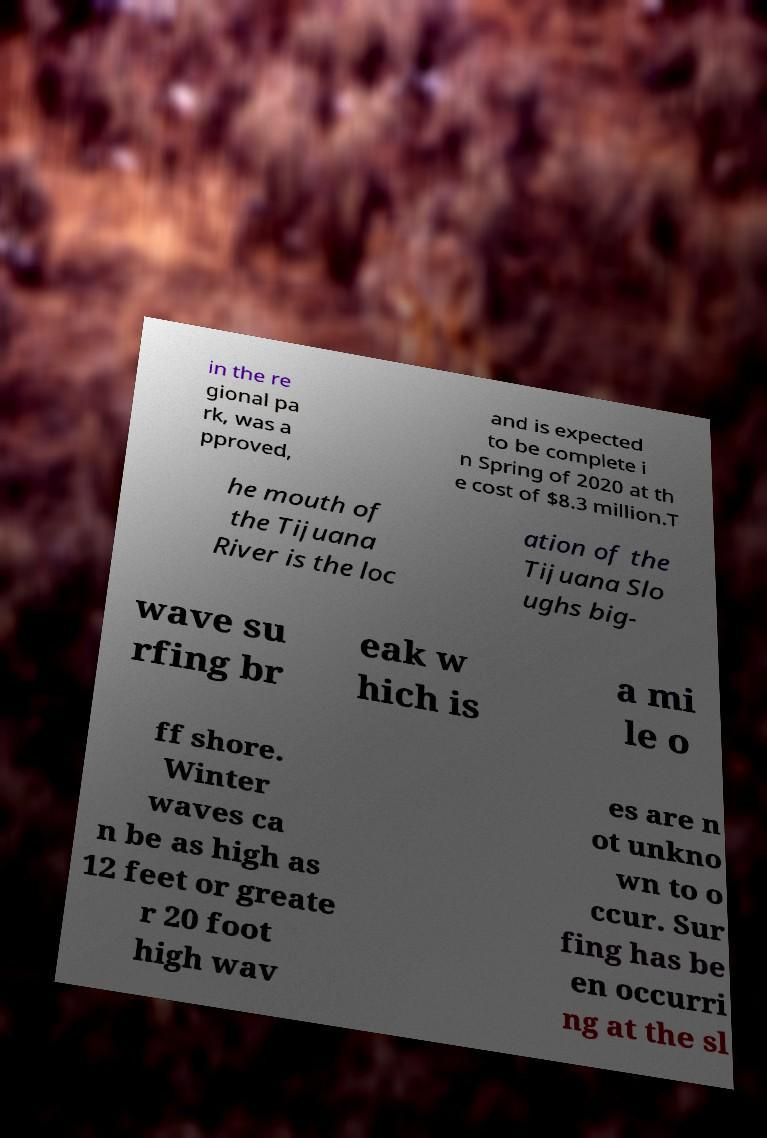Please identify and transcribe the text found in this image. in the re gional pa rk, was a pproved, and is expected to be complete i n Spring of 2020 at th e cost of $8.3 million.T he mouth of the Tijuana River is the loc ation of the Tijuana Slo ughs big- wave su rfing br eak w hich is a mi le o ff shore. Winter waves ca n be as high as 12 feet or greate r 20 foot high wav es are n ot unkno wn to o ccur. Sur fing has be en occurri ng at the sl 